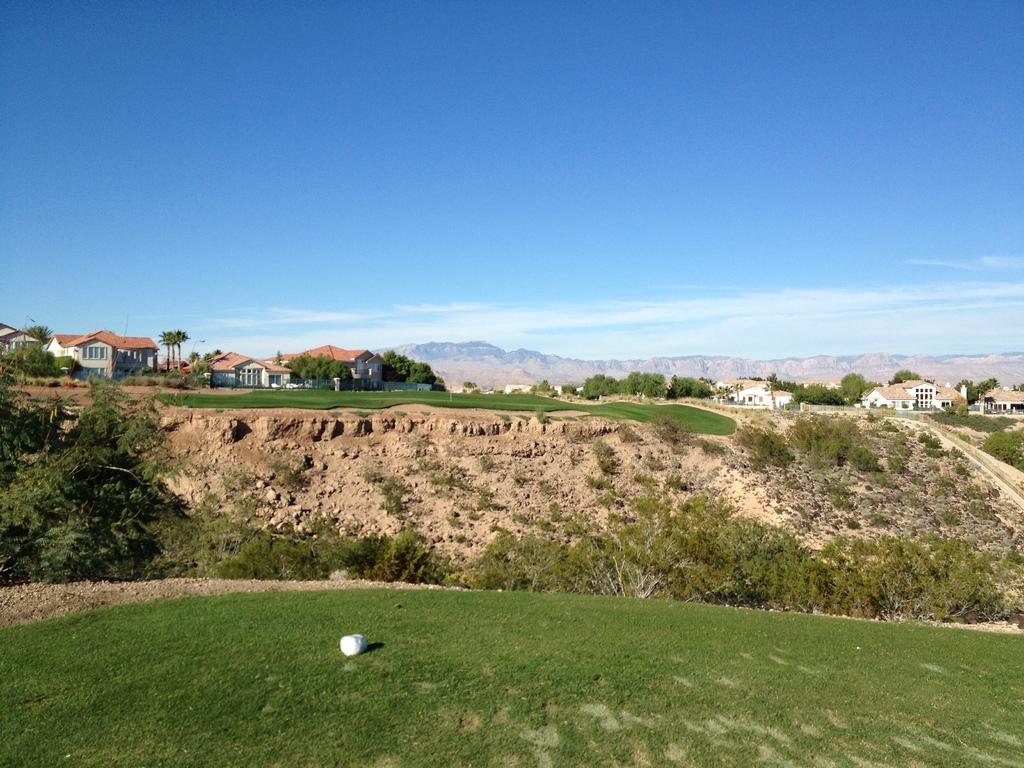Please provide a concise description of this image. In this image we can see grass on the ground. Also there are trees. In the background there are buildings, trees, hills and sky with clouds. 